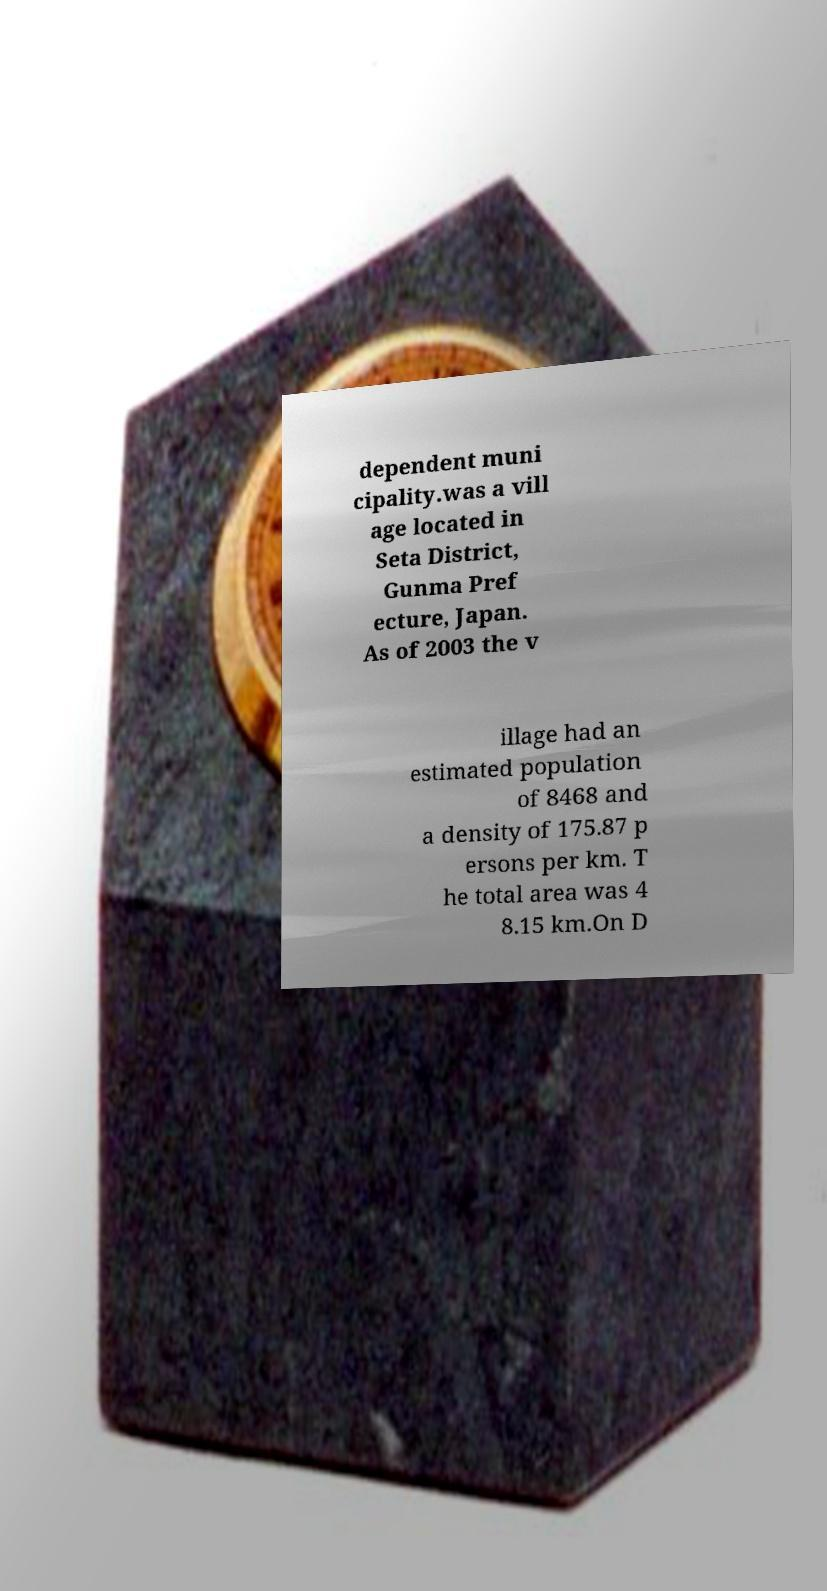Can you accurately transcribe the text from the provided image for me? dependent muni cipality.was a vill age located in Seta District, Gunma Pref ecture, Japan. As of 2003 the v illage had an estimated population of 8468 and a density of 175.87 p ersons per km. T he total area was 4 8.15 km.On D 